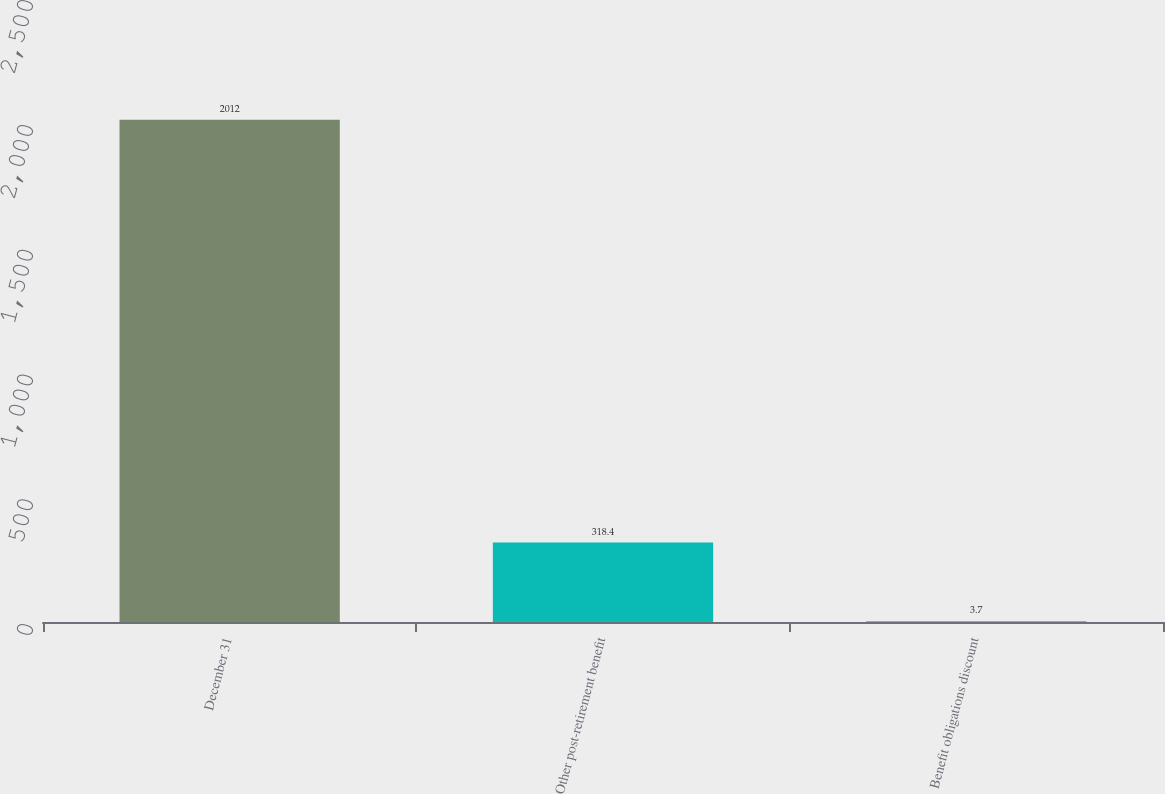<chart> <loc_0><loc_0><loc_500><loc_500><bar_chart><fcel>December 31<fcel>Other post-retirement benefit<fcel>Benefit obligations discount<nl><fcel>2012<fcel>318.4<fcel>3.7<nl></chart> 